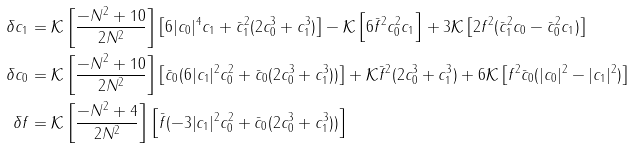<formula> <loc_0><loc_0><loc_500><loc_500>\delta c _ { 1 } & = \mathcal { K } \left [ \frac { - N ^ { 2 } + 1 0 } { 2 N ^ { 2 } } \right ] \left [ 6 | c _ { 0 } | ^ { 4 } c _ { 1 } + \bar { c } _ { 1 } ^ { 2 } ( 2 c _ { 0 } ^ { 3 } + c _ { 1 } ^ { 3 } ) \right ] - \mathcal { K } \left [ 6 \bar { f } ^ { 2 } c _ { 0 } ^ { 2 } c _ { 1 } \right ] + 3 \mathcal { K } \left [ 2 f ^ { 2 } ( \bar { c } _ { 1 } ^ { 2 } c _ { 0 } - \bar { c } _ { 0 } ^ { 2 } c _ { 1 } ) \right ] \\ \delta c _ { 0 } & = \mathcal { K } \left [ \frac { - N ^ { 2 } + 1 0 } { 2 N ^ { 2 } } \right ] \left [ \bar { c } _ { 0 } ( 6 | c _ { 1 } | ^ { 2 } c _ { 0 } ^ { 2 } + \bar { c } _ { 0 } ( 2 c _ { 0 } ^ { 3 } + c _ { 1 } ^ { 3 } ) ) \right ] + \mathcal { K } \bar { f } ^ { 2 } ( 2 c _ { 0 } ^ { 3 } + c _ { 1 } ^ { 3 } ) + 6 \mathcal { K } \left [ f ^ { 2 } \bar { c } _ { 0 } ( | c _ { 0 } | ^ { 2 } - | c _ { 1 } | ^ { 2 } ) \right ] \\ \delta f & = \mathcal { K } \left [ \frac { - N ^ { 2 } + 4 } { 2 N ^ { 2 } } \right ] \left [ \bar { f } ( - 3 | c _ { 1 } | ^ { 2 } c _ { 0 } ^ { 2 } + \bar { c } _ { 0 } ( 2 c _ { 0 } ^ { 3 } + c _ { 1 } ^ { 3 } ) ) \right ]</formula> 